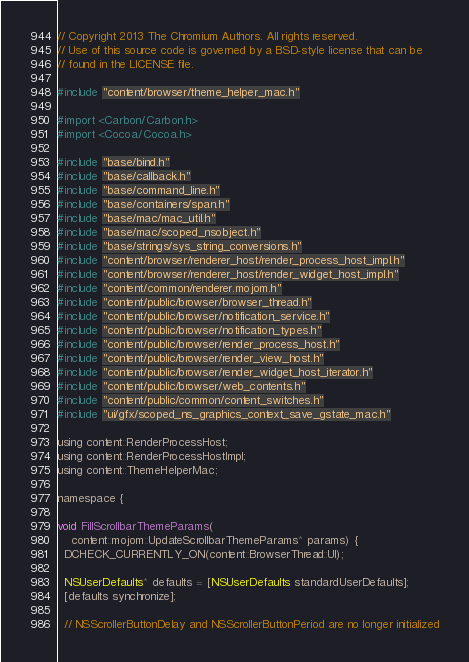Convert code to text. <code><loc_0><loc_0><loc_500><loc_500><_ObjectiveC_>// Copyright 2013 The Chromium Authors. All rights reserved.
// Use of this source code is governed by a BSD-style license that can be
// found in the LICENSE file.

#include "content/browser/theme_helper_mac.h"

#import <Carbon/Carbon.h>
#import <Cocoa/Cocoa.h>

#include "base/bind.h"
#include "base/callback.h"
#include "base/command_line.h"
#include "base/containers/span.h"
#include "base/mac/mac_util.h"
#include "base/mac/scoped_nsobject.h"
#include "base/strings/sys_string_conversions.h"
#include "content/browser/renderer_host/render_process_host_impl.h"
#include "content/browser/renderer_host/render_widget_host_impl.h"
#include "content/common/renderer.mojom.h"
#include "content/public/browser/browser_thread.h"
#include "content/public/browser/notification_service.h"
#include "content/public/browser/notification_types.h"
#include "content/public/browser/render_process_host.h"
#include "content/public/browser/render_view_host.h"
#include "content/public/browser/render_widget_host_iterator.h"
#include "content/public/browser/web_contents.h"
#include "content/public/common/content_switches.h"
#include "ui/gfx/scoped_ns_graphics_context_save_gstate_mac.h"

using content::RenderProcessHost;
using content::RenderProcessHostImpl;
using content::ThemeHelperMac;

namespace {

void FillScrollbarThemeParams(
    content::mojom::UpdateScrollbarThemeParams* params) {
  DCHECK_CURRENTLY_ON(content::BrowserThread::UI);

  NSUserDefaults* defaults = [NSUserDefaults standardUserDefaults];
  [defaults synchronize];

  // NSScrollerButtonDelay and NSScrollerButtonPeriod are no longer initialized</code> 